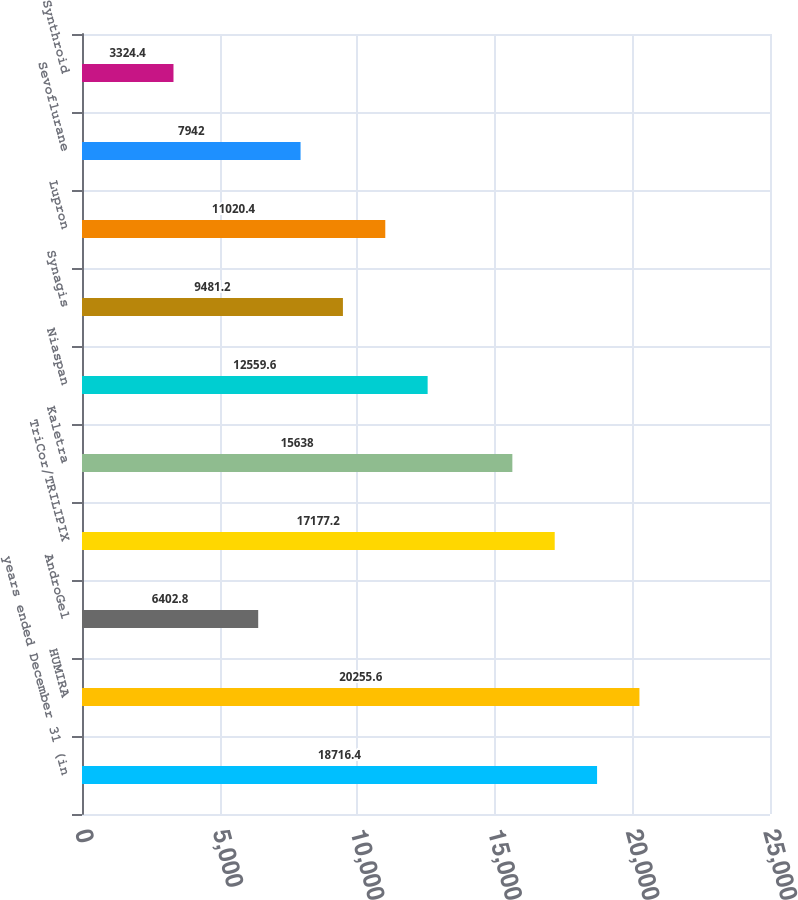Convert chart to OTSL. <chart><loc_0><loc_0><loc_500><loc_500><bar_chart><fcel>years ended December 31 (in<fcel>HUMIRA<fcel>AndroGel<fcel>TriCor/TRILIPIX<fcel>Kaletra<fcel>Niaspan<fcel>Synagis<fcel>Lupron<fcel>Sevoflurane<fcel>Synthroid<nl><fcel>18716.4<fcel>20255.6<fcel>6402.8<fcel>17177.2<fcel>15638<fcel>12559.6<fcel>9481.2<fcel>11020.4<fcel>7942<fcel>3324.4<nl></chart> 